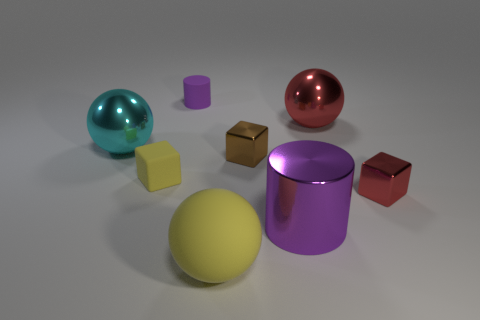Is the number of small red shiny objects on the left side of the large purple cylinder less than the number of red blocks that are in front of the yellow block?
Offer a very short reply. Yes. How many other objects are there of the same material as the small purple cylinder?
Ensure brevity in your answer.  2. Does the large cyan sphere have the same material as the small purple thing?
Provide a short and direct response. No. How many other objects are there of the same size as the rubber ball?
Provide a succinct answer. 3. There is a red object that is behind the red thing that is in front of the cyan shiny object; what is its size?
Your answer should be very brief. Large. There is a rubber thing that is to the right of the purple cylinder left of the yellow object to the right of the small purple rubber object; what is its color?
Your response must be concise. Yellow. How big is the rubber thing that is both in front of the purple rubber cylinder and on the right side of the tiny yellow object?
Provide a succinct answer. Large. What number of other objects are the same shape as the tiny yellow object?
Provide a succinct answer. 2. What number of cylinders are small metal things or tiny brown objects?
Provide a short and direct response. 0. There is a tiny red shiny thing to the right of the small matte thing that is behind the big cyan shiny thing; is there a shiny block that is behind it?
Keep it short and to the point. Yes. 